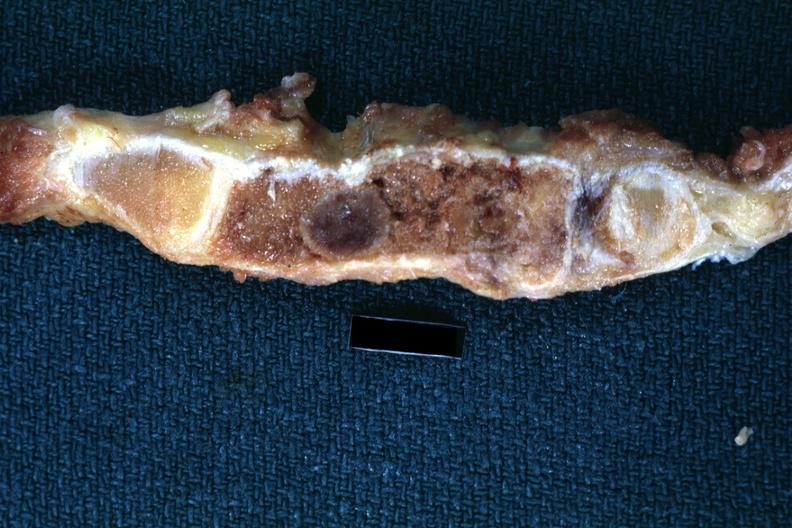what does this image show?
Answer the question using a single word or phrase. Fixed tissue saggital section sternum with typical plasmacytoma shown close-up very good 